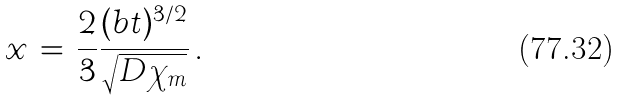<formula> <loc_0><loc_0><loc_500><loc_500>x \, = \, \frac { 2 } { 3 } \frac { ( b t ) ^ { 3 / 2 } } { \sqrt { D \chi _ { m } } } \, .</formula> 